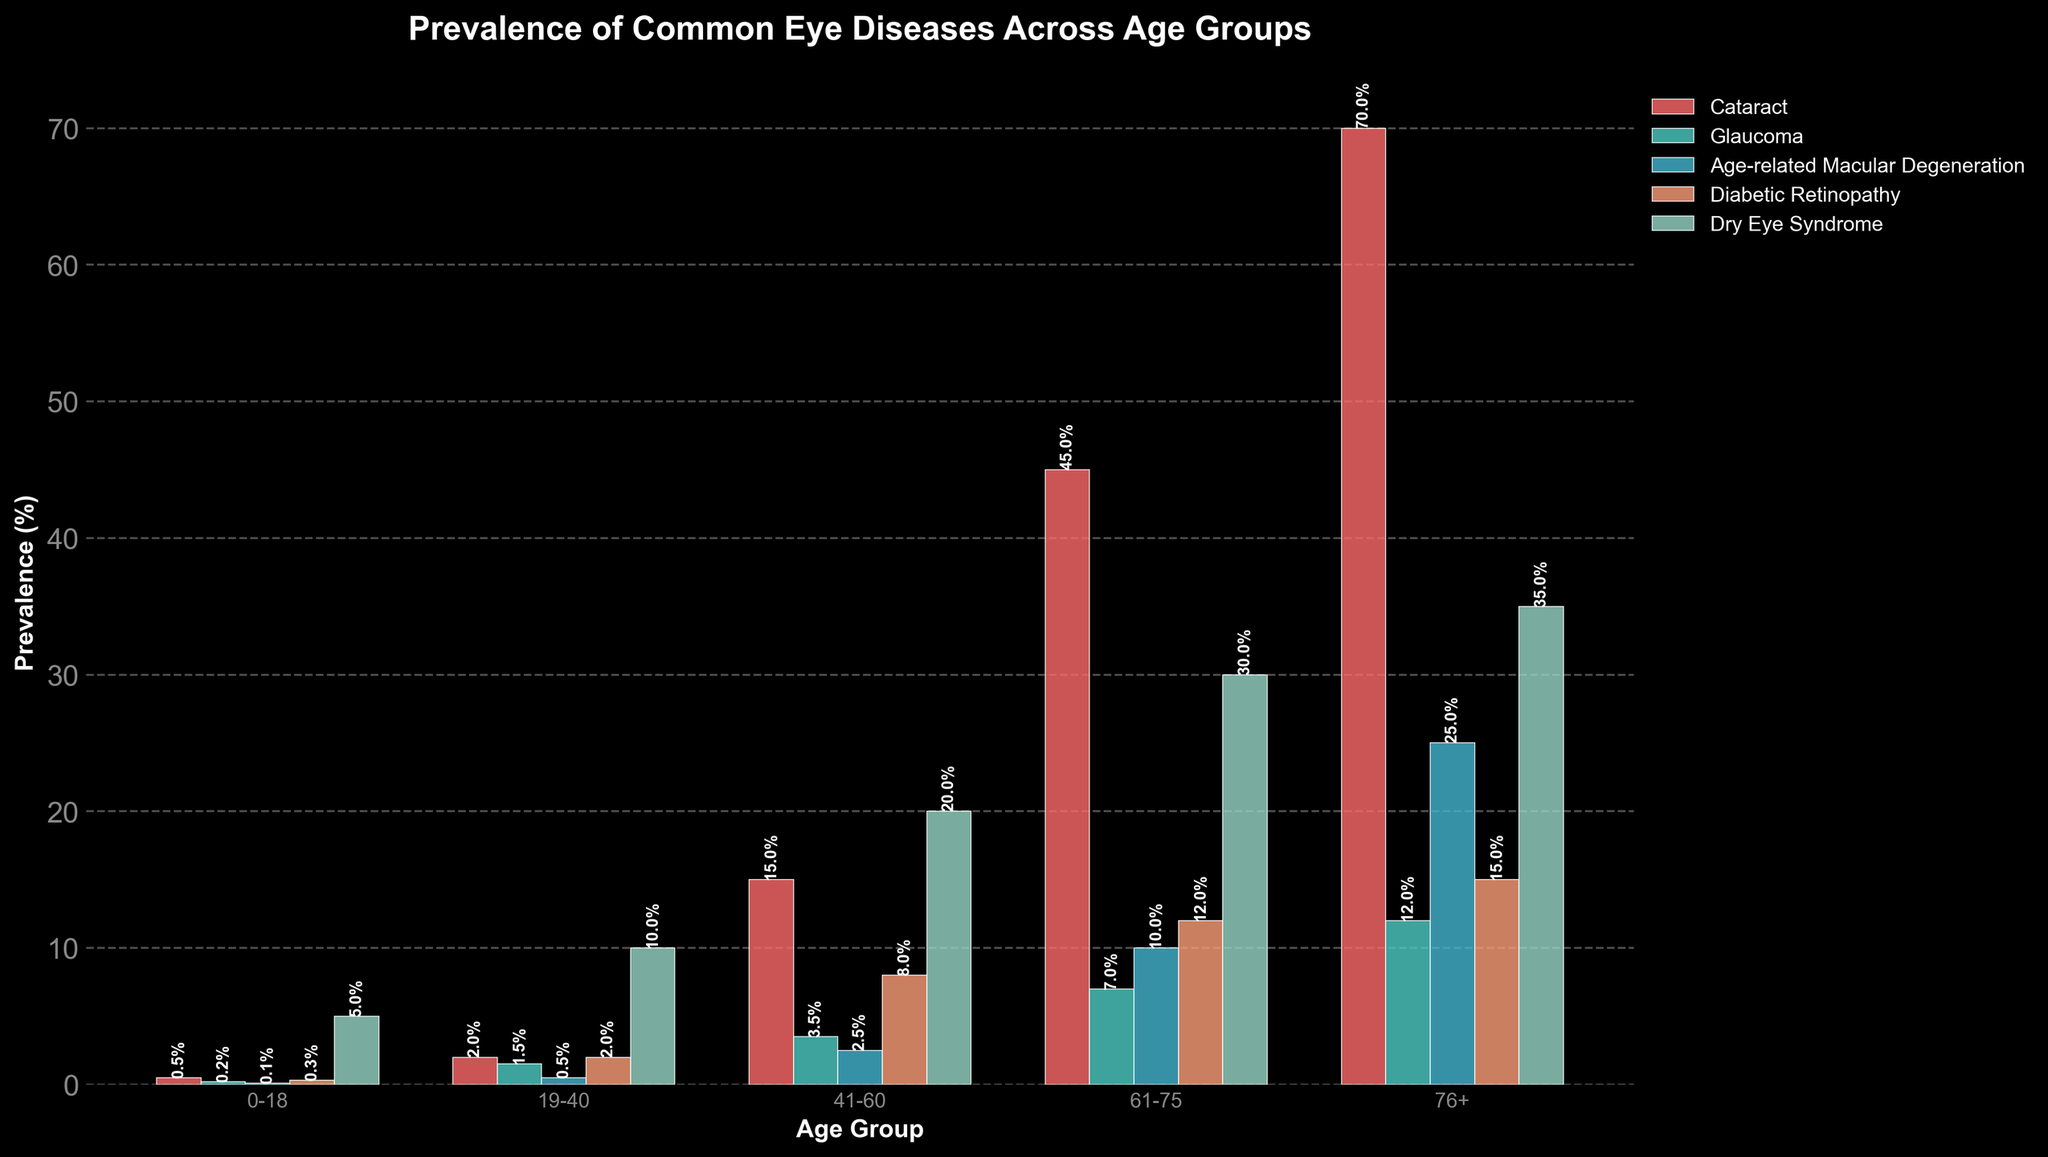What is the prevalence of cataract in the 19-40 age group? Look at the bar corresponding to 'Cataract' in the 19-40 age group, the height represents the prevalence.
Answer: 2.0% Which age group has the highest prevalence of dry eye syndrome? Compare the heights of the bars for 'Dry Eye Syndrome' across all age groups. The tallest bar indicates the highest prevalence.
Answer: 76+ Compare the prevalence of glaucoma and diabetic retinopathy in the 61-75 age group. Which is higher and by how much? Look at the bars for 'Glaucoma' and 'Diabetic Retinopathy' in the 61-75 age group. Subtract the smaller value from the larger value.
Answer: Diabetic Retinopathy is higher by 5% What's the average prevalence of age-related macular degeneration in the age groups 0-18, 19-40, and 41-60? Add the prevalence percentages for 'Age-related Macular Degeneration' in age groups 0-18, 19-40, and 41-60 and divide by 3. 
(0.1 + 0.5 + 2.5) / 3 = 1.0333
Answer: 1.03% What is the difference in prevalence of cataract between the 41-60 and 76+ age groups? Subtract the prevalence of cataract in the 41-60 age group from the prevalence in the 76+ age group. 
70.0 - 15.0 = 55.0
Answer: 55% Which eye disease has the least prevalence in the 76+ age group, and what is its value? Compare all bars for the 76+ age group and identify the shortest bar to find the least prevalence.
Answer: Glaucoma, 12.0% How does the prevalence of dry eye syndrome change as the age group increases from 0-18 to 76+? Observe the trend in the heights of the 'Dry Eye Syndrome' bars across the age groups, noting whether they increase or decrease.
Answer: It increases What's the total prevalence of all eye diseases combined in the 41-60 age group? Sum the prevalence percentages of all the eye diseases in the 41-60 age group.
15.0 + 3.5 + 2.5 + 8.0 + 20.0 = 49.0
Answer: 49% Which age group shows the highest prevalence of any single eye condition, and what is the condition? Scan through the chart to find the single highest prevalence value across all conditions and age groups.
Answer: 76+, Cataract What is the combined prevalence of glaucoma in the age groups 0-18 and 19-40? Add the prevalence percentages of glaucoma in the 0-18 and 19-40 age groups.
0.2 + 1.5 = 1.7
Answer: 1.7% 